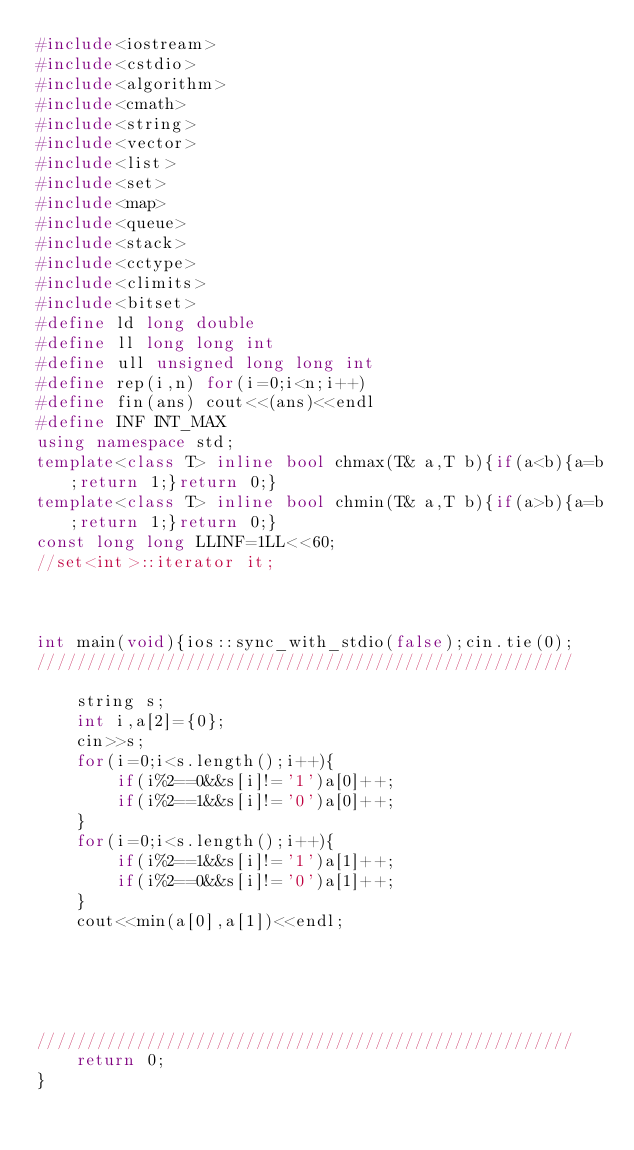<code> <loc_0><loc_0><loc_500><loc_500><_C++_>#include<iostream>
#include<cstdio>
#include<algorithm>
#include<cmath>
#include<string>
#include<vector>
#include<list>
#include<set>
#include<map>
#include<queue>
#include<stack>
#include<cctype>
#include<climits>
#include<bitset>
#define ld long double
#define ll long long int
#define ull unsigned long long int
#define rep(i,n) for(i=0;i<n;i++)
#define fin(ans) cout<<(ans)<<endl
#define INF INT_MAX
using namespace std;
template<class T> inline bool chmax(T& a,T b){if(a<b){a=b;return 1;}return 0;}
template<class T> inline bool chmin(T& a,T b){if(a>b){a=b;return 1;}return 0;}
const long long LLINF=1LL<<60;
//set<int>::iterator it;



int main(void){ios::sync_with_stdio(false);cin.tie(0);
//////////////////////////////////////////////////////
	
	string s;
	int i,a[2]={0};
	cin>>s;
	for(i=0;i<s.length();i++){
		if(i%2==0&&s[i]!='1')a[0]++;
		if(i%2==1&&s[i]!='0')a[0]++;
	}
	for(i=0;i<s.length();i++){
		if(i%2==1&&s[i]!='1')a[1]++;
		if(i%2==0&&s[i]!='0')a[1]++;
	}
	cout<<min(a[0],a[1])<<endl;
	
	
	
	
	
//////////////////////////////////////////////////////
	return 0;
}
</code> 